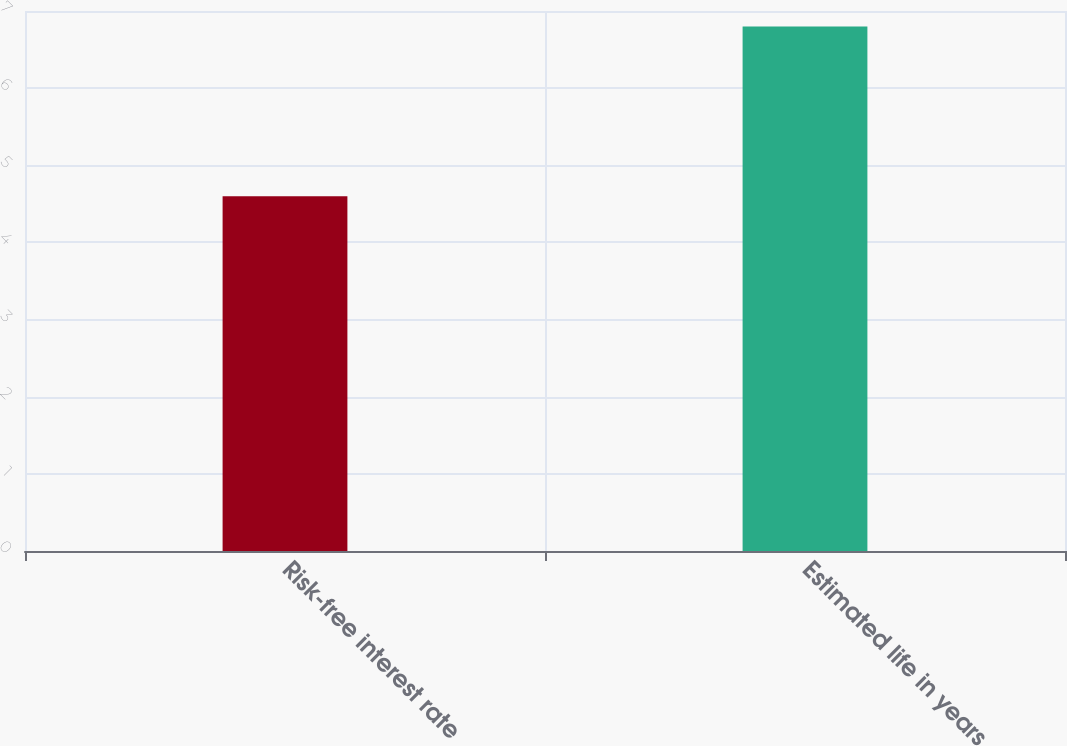Convert chart to OTSL. <chart><loc_0><loc_0><loc_500><loc_500><bar_chart><fcel>Risk-free interest rate<fcel>Estimated life in years<nl><fcel>4.6<fcel>6.8<nl></chart> 